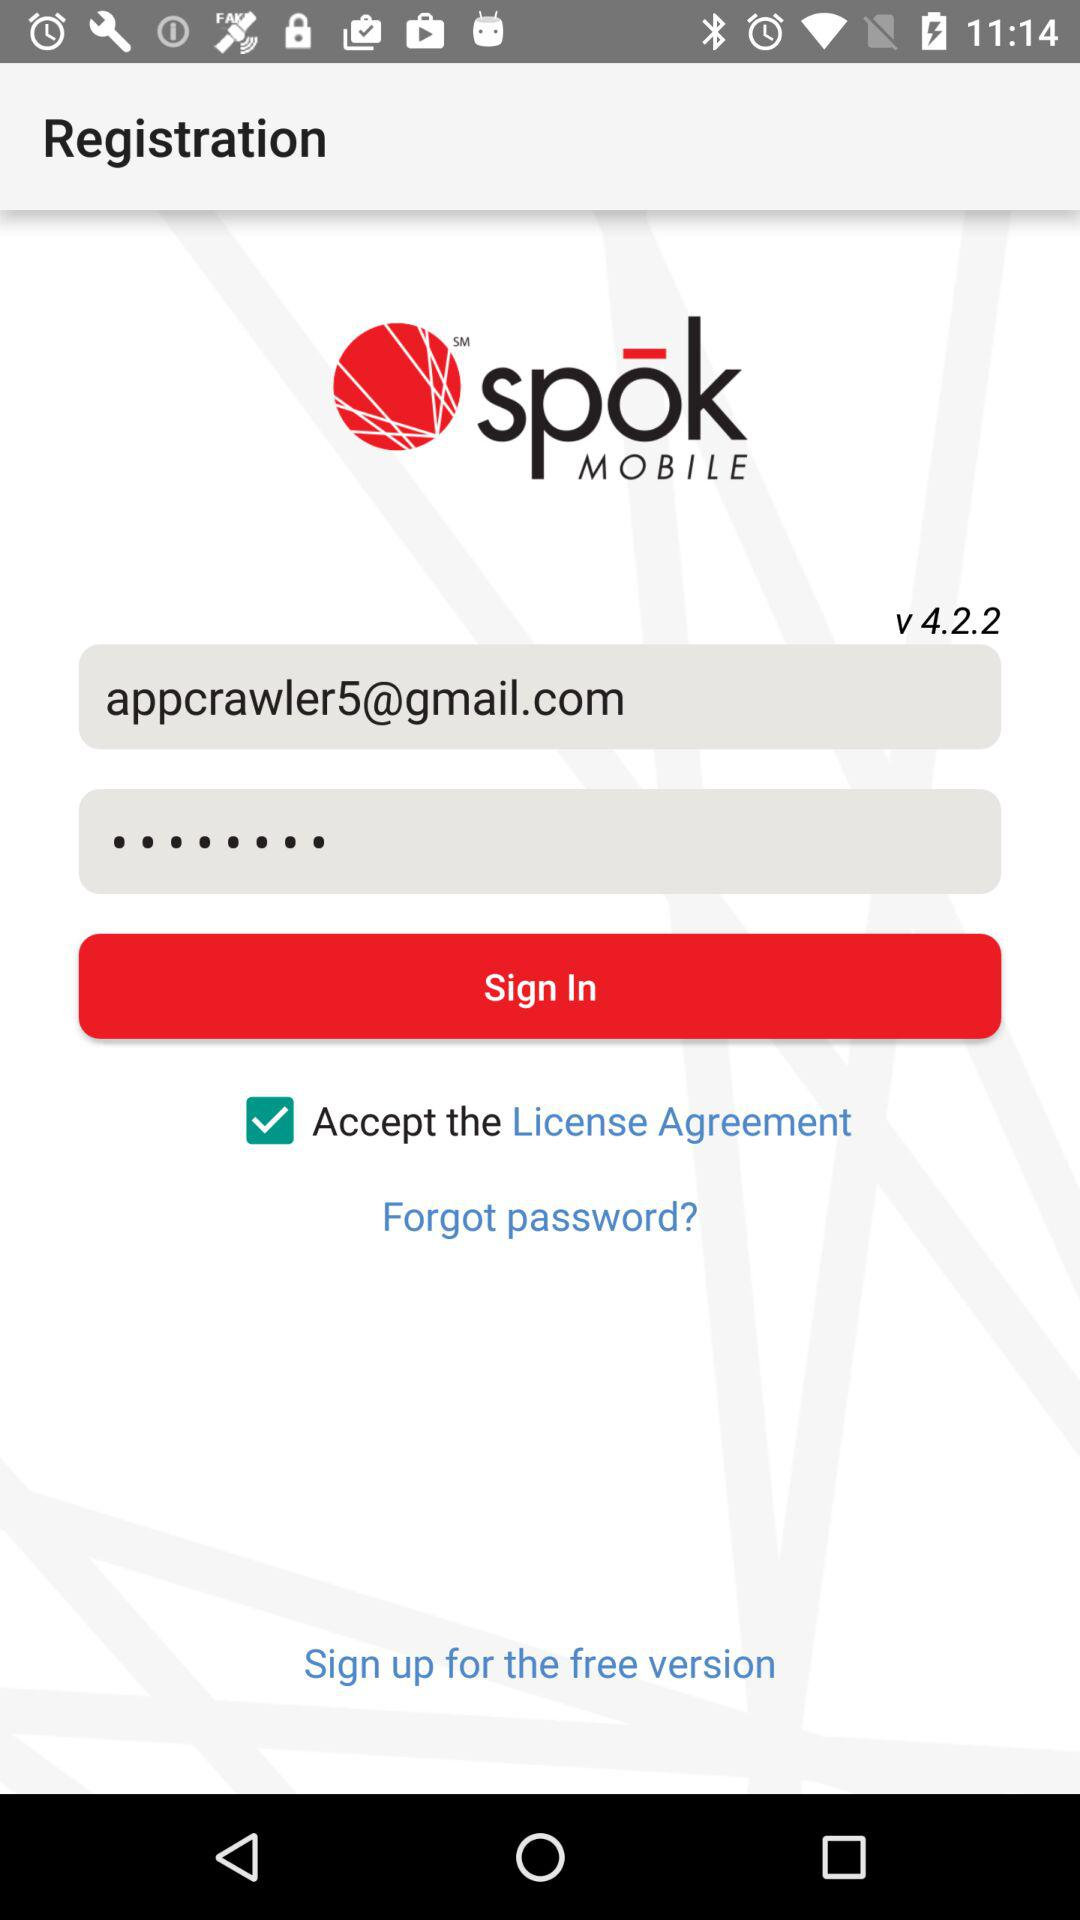What is the name of the application? The name of the application is "spok MOBILE". 